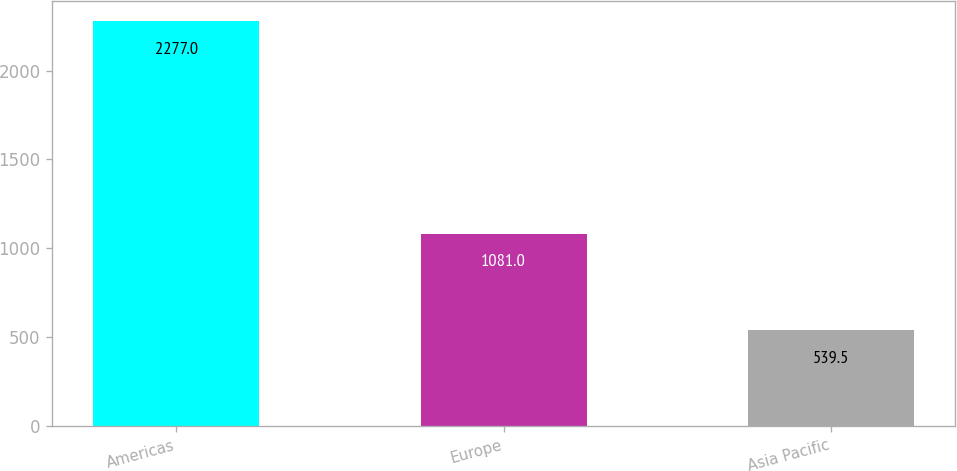Convert chart. <chart><loc_0><loc_0><loc_500><loc_500><bar_chart><fcel>Americas<fcel>Europe<fcel>Asia Pacific<nl><fcel>2277<fcel>1081<fcel>539.5<nl></chart> 